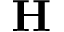Convert formula to latex. <formula><loc_0><loc_0><loc_500><loc_500>\mathbf H</formula> 